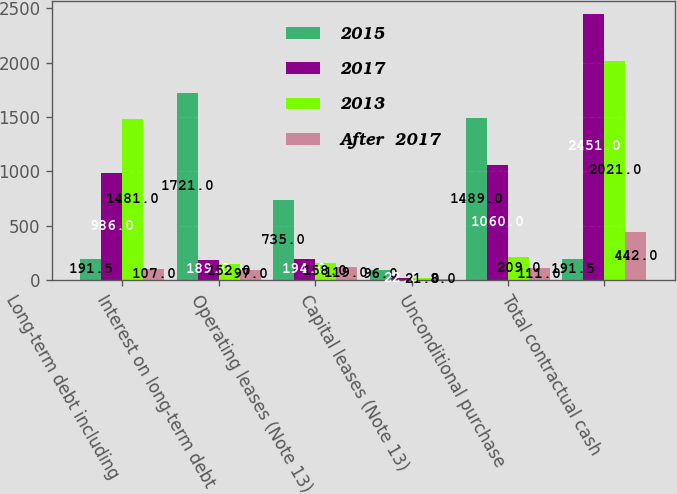Convert chart to OTSL. <chart><loc_0><loc_0><loc_500><loc_500><stacked_bar_chart><ecel><fcel>Long-term debt including<fcel>Interest on long-term debt<fcel>Operating leases (Note 13)<fcel>Capital leases (Note 13)<fcel>Unconditional purchase<fcel>Total contractual cash<nl><fcel>2015<fcel>191.5<fcel>1721<fcel>735<fcel>96<fcel>1489<fcel>191.5<nl><fcel>2017<fcel>986<fcel>189<fcel>194<fcel>22<fcel>1060<fcel>2451<nl><fcel>2013<fcel>1481<fcel>152<fcel>158<fcel>21<fcel>209<fcel>2021<nl><fcel>After  2017<fcel>107<fcel>97<fcel>119<fcel>8<fcel>111<fcel>442<nl></chart> 